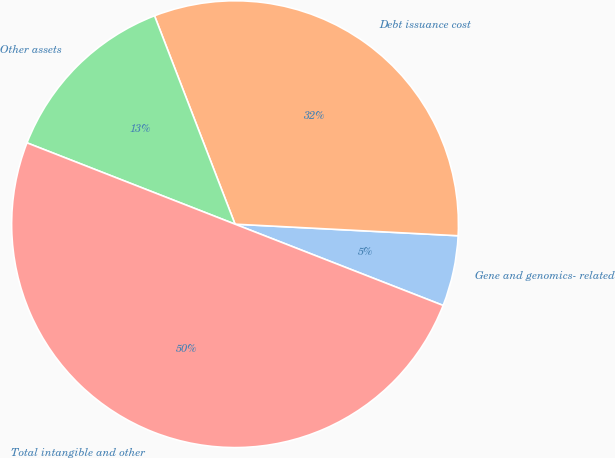Convert chart to OTSL. <chart><loc_0><loc_0><loc_500><loc_500><pie_chart><fcel>Gene and genomics- related<fcel>Debt issuance cost<fcel>Other assets<fcel>Total intangible and other<nl><fcel>5.1%<fcel>31.69%<fcel>13.2%<fcel>50.0%<nl></chart> 